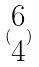Convert formula to latex. <formula><loc_0><loc_0><loc_500><loc_500>( \begin{matrix} 6 \\ 4 \end{matrix} )</formula> 